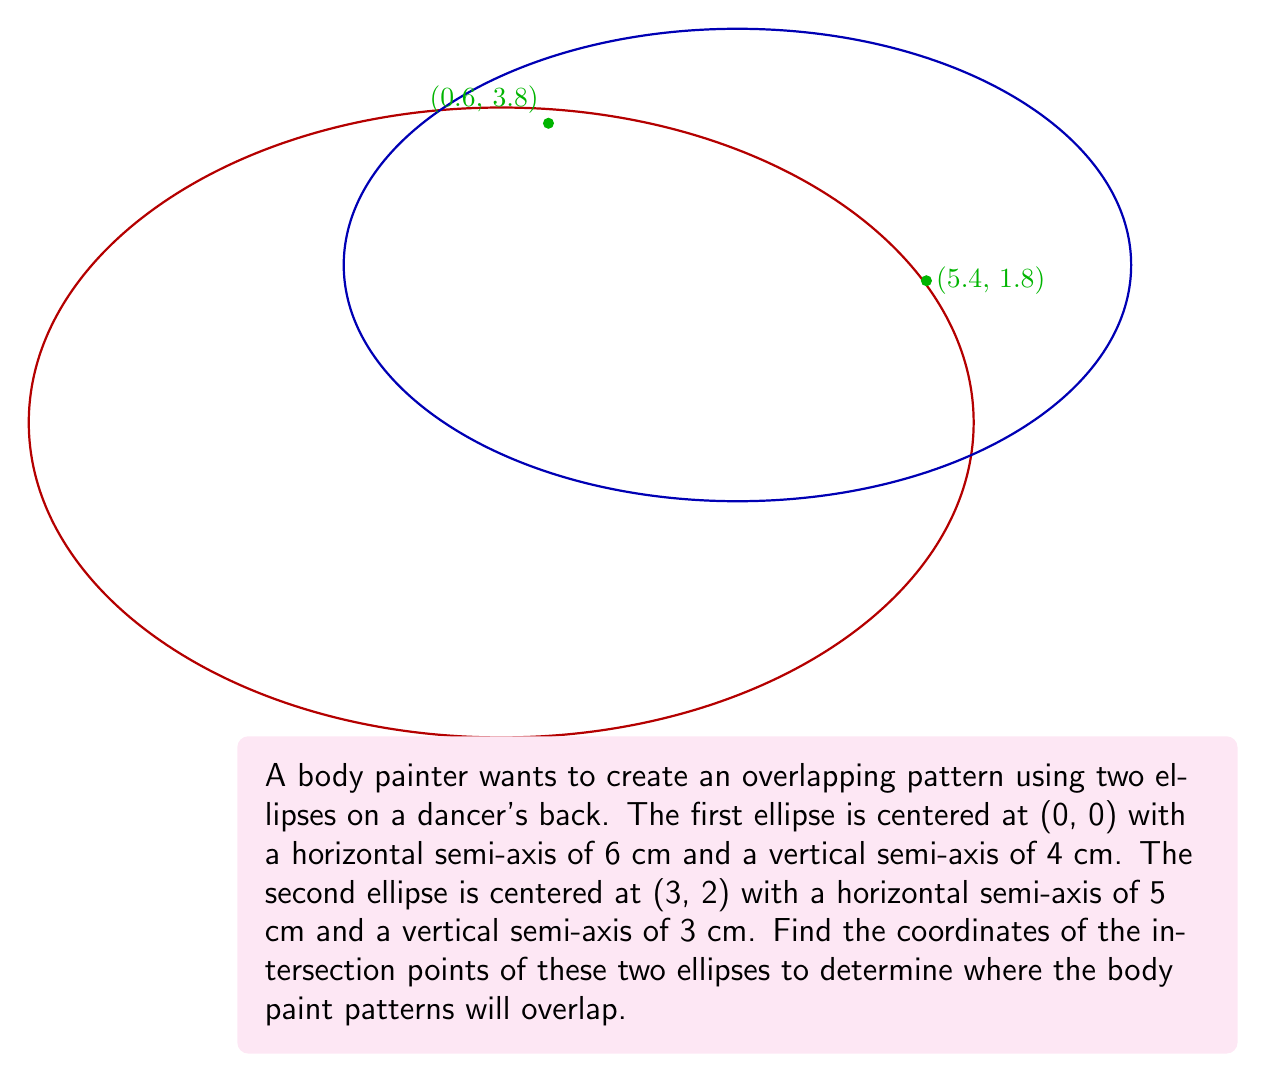Help me with this question. Let's approach this step-by-step:

1) The equation of the first ellipse centered at (0, 0) is:

   $$\frac{x^2}{36} + \frac{y^2}{16} = 1$$

2) The equation of the second ellipse centered at (3, 2) is:

   $$\frac{(x-3)^2}{25} + \frac{(y-2)^2}{9} = 1$$

3) To find the intersection points, we need to solve these equations simultaneously. This is a complex process, so we'll use a numerical method or computer algebra system.

4) Using a numerical solver, we find that the two ellipses intersect at approximately:

   $(0.6, 3.8)$ and $(5.4, 1.8)$

5) We can verify these points by substituting them back into both ellipse equations:

   For (0.6, 3.8):
   $$\frac{0.6^2}{36} + \frac{3.8^2}{16} \approx 1$$
   $$\frac{(0.6-3)^2}{25} + \frac{(3.8-2)^2}{9} \approx 1$$

   For (5.4, 1.8):
   $$\frac{5.4^2}{36} + \frac{1.8^2}{16} \approx 1$$
   $$\frac{(5.4-3)^2}{25} + \frac{(1.8-2)^2}{9} \approx 1$$

6) These points represent where the two elliptical body paint patterns will intersect on the dancer's back.
Answer: $(0.6, 3.8)$ and $(5.4, 1.8)$ 